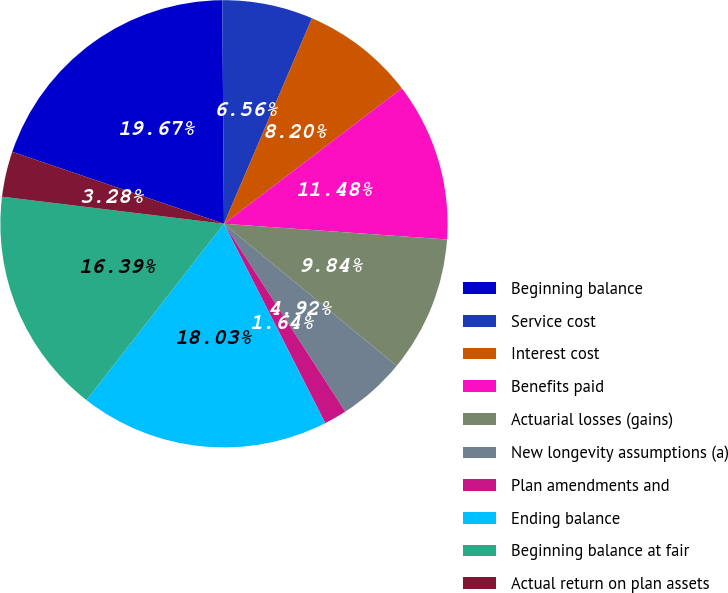Convert chart to OTSL. <chart><loc_0><loc_0><loc_500><loc_500><pie_chart><fcel>Beginning balance<fcel>Service cost<fcel>Interest cost<fcel>Benefits paid<fcel>Actuarial losses (gains)<fcel>New longevity assumptions (a)<fcel>Plan amendments and<fcel>Ending balance<fcel>Beginning balance at fair<fcel>Actual return on plan assets<nl><fcel>19.67%<fcel>6.56%<fcel>8.2%<fcel>11.48%<fcel>9.84%<fcel>4.92%<fcel>1.64%<fcel>18.03%<fcel>16.39%<fcel>3.28%<nl></chart> 